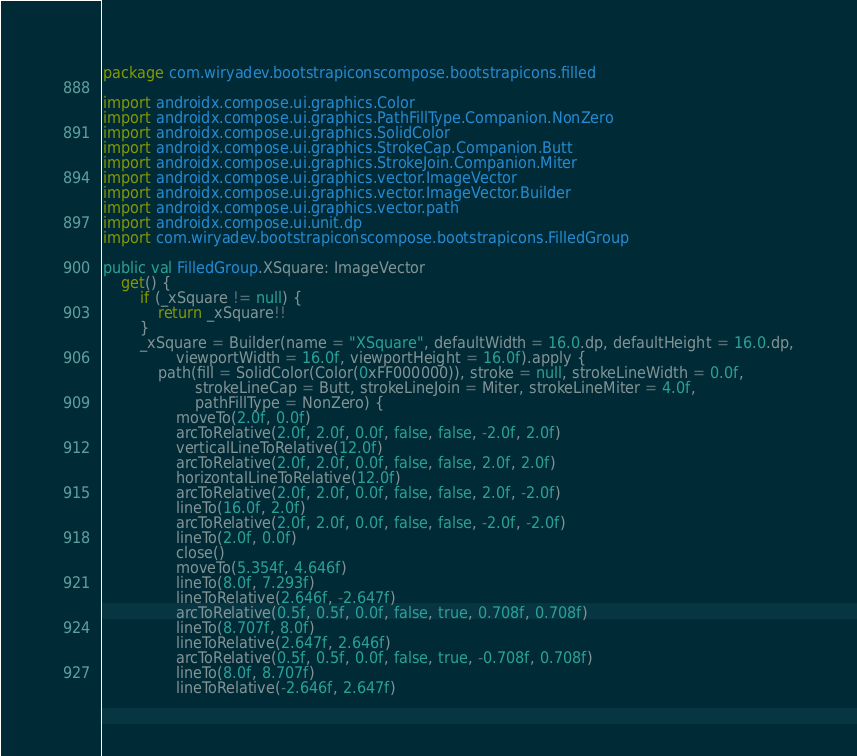Convert code to text. <code><loc_0><loc_0><loc_500><loc_500><_Kotlin_>package com.wiryadev.bootstrapiconscompose.bootstrapicons.filled

import androidx.compose.ui.graphics.Color
import androidx.compose.ui.graphics.PathFillType.Companion.NonZero
import androidx.compose.ui.graphics.SolidColor
import androidx.compose.ui.graphics.StrokeCap.Companion.Butt
import androidx.compose.ui.graphics.StrokeJoin.Companion.Miter
import androidx.compose.ui.graphics.vector.ImageVector
import androidx.compose.ui.graphics.vector.ImageVector.Builder
import androidx.compose.ui.graphics.vector.path
import androidx.compose.ui.unit.dp
import com.wiryadev.bootstrapiconscompose.bootstrapicons.FilledGroup

public val FilledGroup.XSquare: ImageVector
    get() {
        if (_xSquare != null) {
            return _xSquare!!
        }
        _xSquare = Builder(name = "XSquare", defaultWidth = 16.0.dp, defaultHeight = 16.0.dp,
                viewportWidth = 16.0f, viewportHeight = 16.0f).apply {
            path(fill = SolidColor(Color(0xFF000000)), stroke = null, strokeLineWidth = 0.0f,
                    strokeLineCap = Butt, strokeLineJoin = Miter, strokeLineMiter = 4.0f,
                    pathFillType = NonZero) {
                moveTo(2.0f, 0.0f)
                arcToRelative(2.0f, 2.0f, 0.0f, false, false, -2.0f, 2.0f)
                verticalLineToRelative(12.0f)
                arcToRelative(2.0f, 2.0f, 0.0f, false, false, 2.0f, 2.0f)
                horizontalLineToRelative(12.0f)
                arcToRelative(2.0f, 2.0f, 0.0f, false, false, 2.0f, -2.0f)
                lineTo(16.0f, 2.0f)
                arcToRelative(2.0f, 2.0f, 0.0f, false, false, -2.0f, -2.0f)
                lineTo(2.0f, 0.0f)
                close()
                moveTo(5.354f, 4.646f)
                lineTo(8.0f, 7.293f)
                lineToRelative(2.646f, -2.647f)
                arcToRelative(0.5f, 0.5f, 0.0f, false, true, 0.708f, 0.708f)
                lineTo(8.707f, 8.0f)
                lineToRelative(2.647f, 2.646f)
                arcToRelative(0.5f, 0.5f, 0.0f, false, true, -0.708f, 0.708f)
                lineTo(8.0f, 8.707f)
                lineToRelative(-2.646f, 2.647f)</code> 